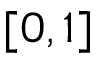<formula> <loc_0><loc_0><loc_500><loc_500>[ 0 , 1 ]</formula> 